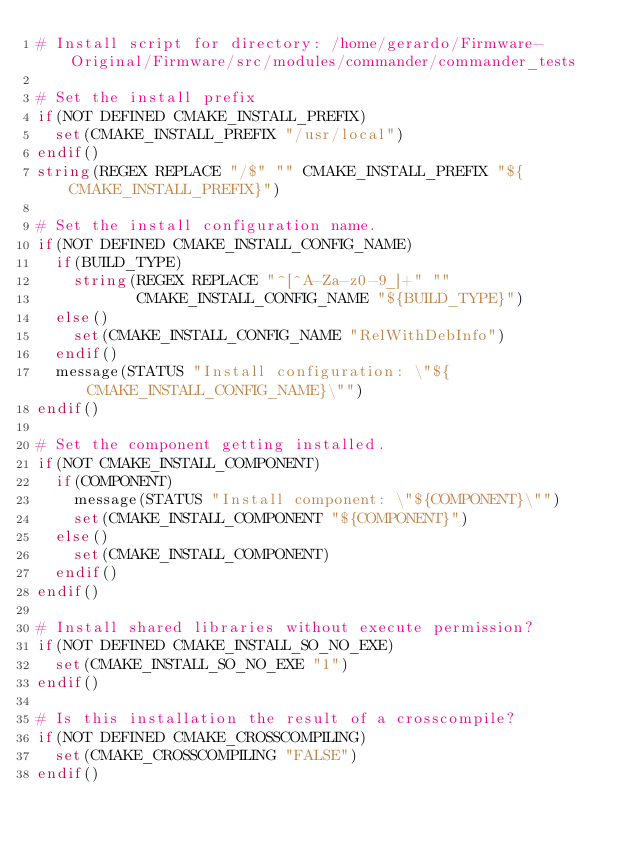Convert code to text. <code><loc_0><loc_0><loc_500><loc_500><_CMake_># Install script for directory: /home/gerardo/Firmware-Original/Firmware/src/modules/commander/commander_tests

# Set the install prefix
if(NOT DEFINED CMAKE_INSTALL_PREFIX)
  set(CMAKE_INSTALL_PREFIX "/usr/local")
endif()
string(REGEX REPLACE "/$" "" CMAKE_INSTALL_PREFIX "${CMAKE_INSTALL_PREFIX}")

# Set the install configuration name.
if(NOT DEFINED CMAKE_INSTALL_CONFIG_NAME)
  if(BUILD_TYPE)
    string(REGEX REPLACE "^[^A-Za-z0-9_]+" ""
           CMAKE_INSTALL_CONFIG_NAME "${BUILD_TYPE}")
  else()
    set(CMAKE_INSTALL_CONFIG_NAME "RelWithDebInfo")
  endif()
  message(STATUS "Install configuration: \"${CMAKE_INSTALL_CONFIG_NAME}\"")
endif()

# Set the component getting installed.
if(NOT CMAKE_INSTALL_COMPONENT)
  if(COMPONENT)
    message(STATUS "Install component: \"${COMPONENT}\"")
    set(CMAKE_INSTALL_COMPONENT "${COMPONENT}")
  else()
    set(CMAKE_INSTALL_COMPONENT)
  endif()
endif()

# Install shared libraries without execute permission?
if(NOT DEFINED CMAKE_INSTALL_SO_NO_EXE)
  set(CMAKE_INSTALL_SO_NO_EXE "1")
endif()

# Is this installation the result of a crosscompile?
if(NOT DEFINED CMAKE_CROSSCOMPILING)
  set(CMAKE_CROSSCOMPILING "FALSE")
endif()

</code> 